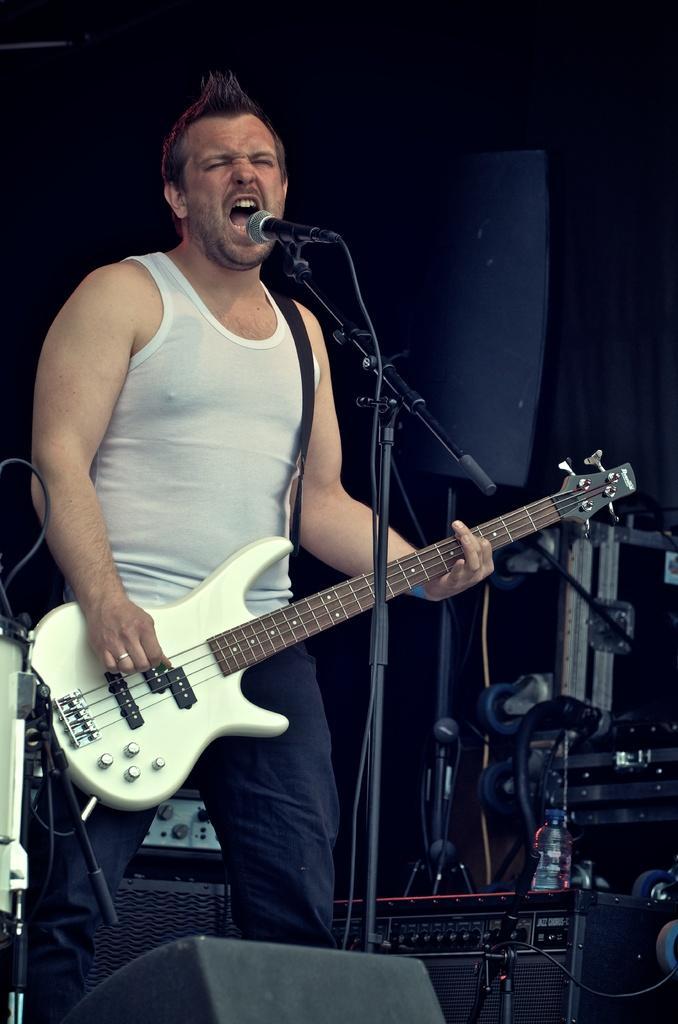Could you give a brief overview of what you see in this image? In this picture I can see a man playing a guitar, there are mike's stands, there is a mike, there are speakers, and in the background there are some objects. 